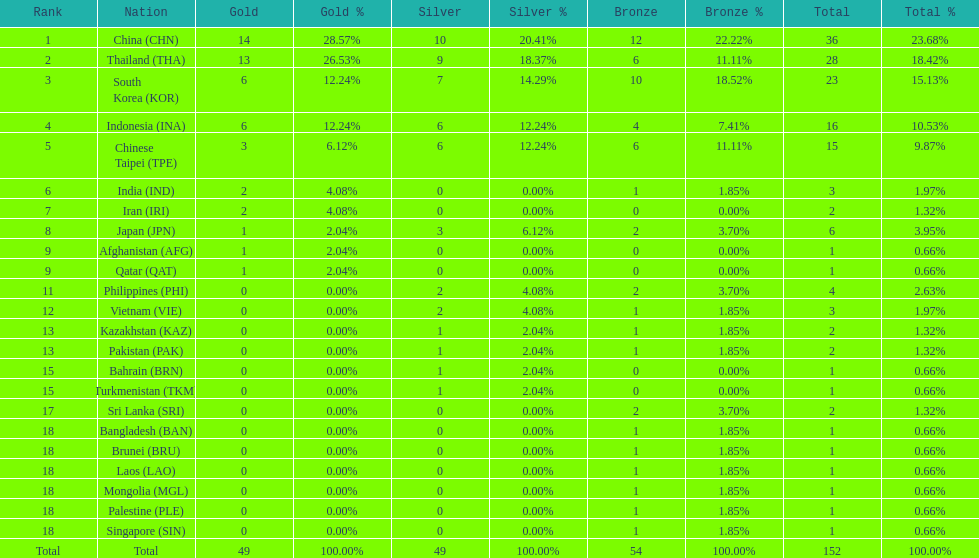How many combined silver medals did china, india, and japan earn ? 13. 